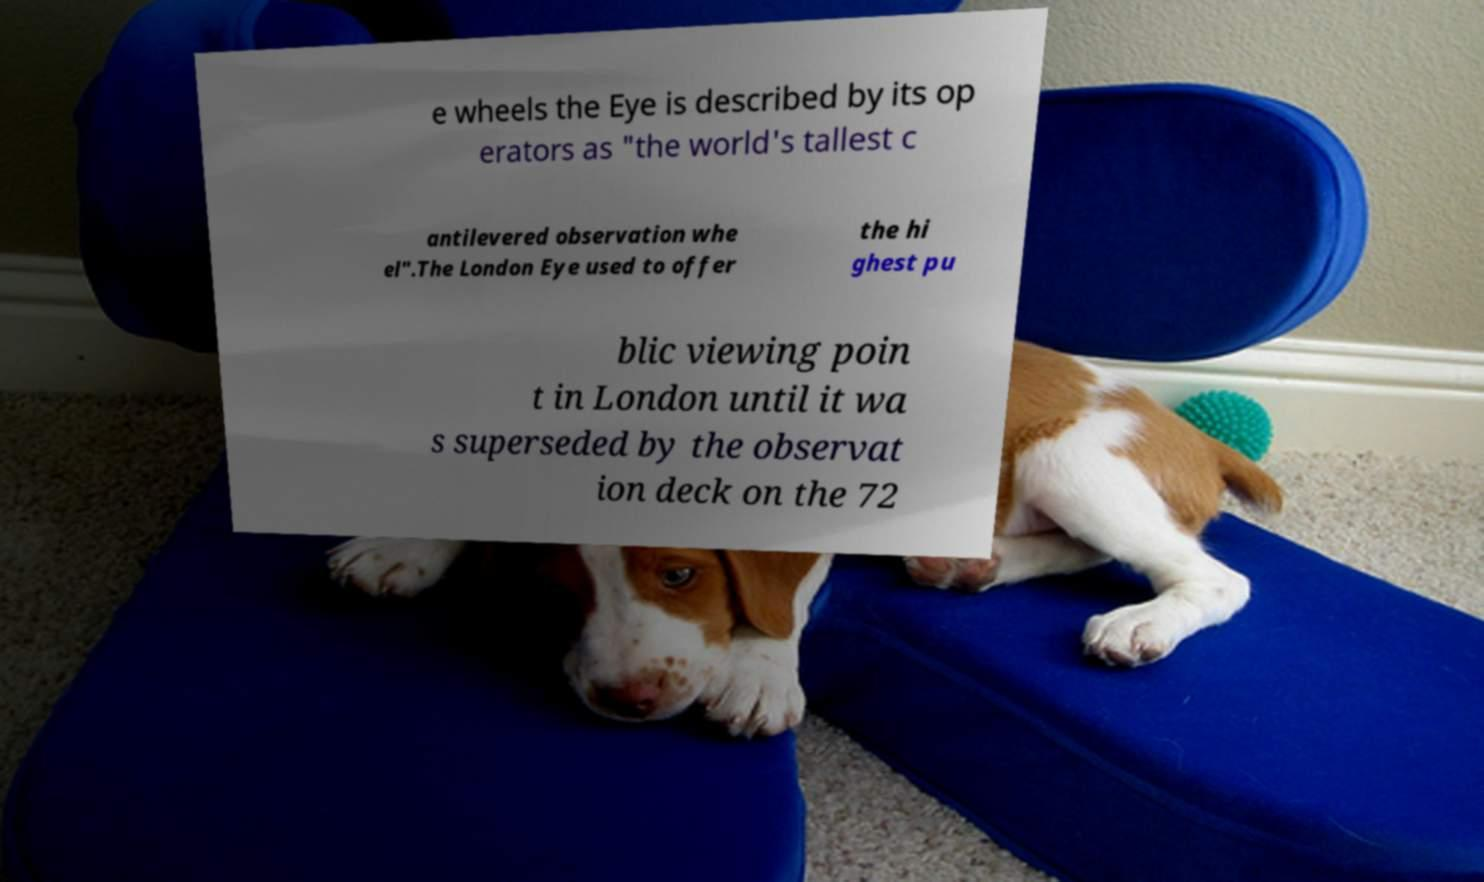Could you assist in decoding the text presented in this image and type it out clearly? e wheels the Eye is described by its op erators as "the world's tallest c antilevered observation whe el".The London Eye used to offer the hi ghest pu blic viewing poin t in London until it wa s superseded by the observat ion deck on the 72 